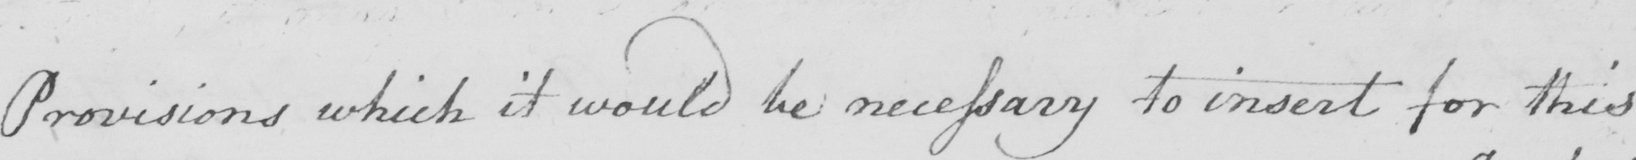What text is written in this handwritten line? Provisions which it would be necessary to insert for this 